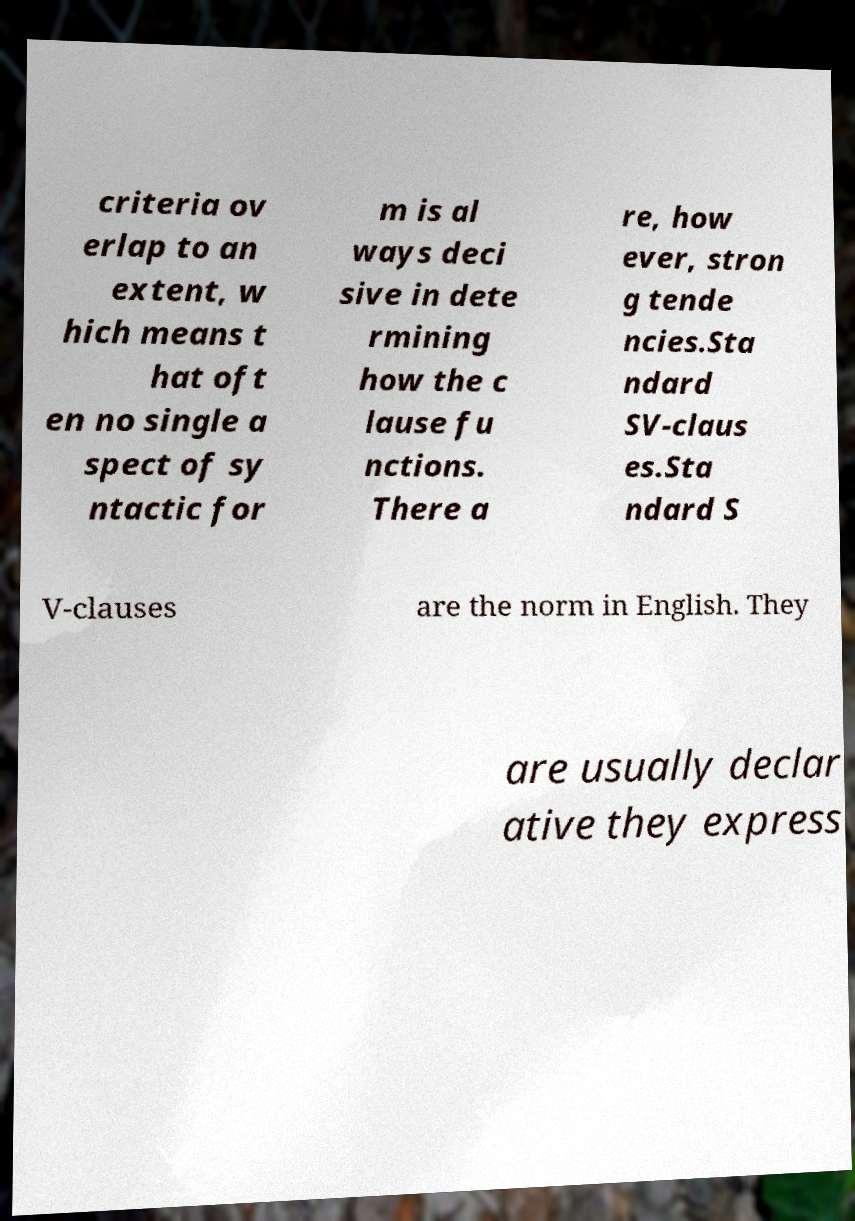Can you read and provide the text displayed in the image?This photo seems to have some interesting text. Can you extract and type it out for me? criteria ov erlap to an extent, w hich means t hat oft en no single a spect of sy ntactic for m is al ways deci sive in dete rmining how the c lause fu nctions. There a re, how ever, stron g tende ncies.Sta ndard SV-claus es.Sta ndard S V-clauses are the norm in English. They are usually declar ative they express 